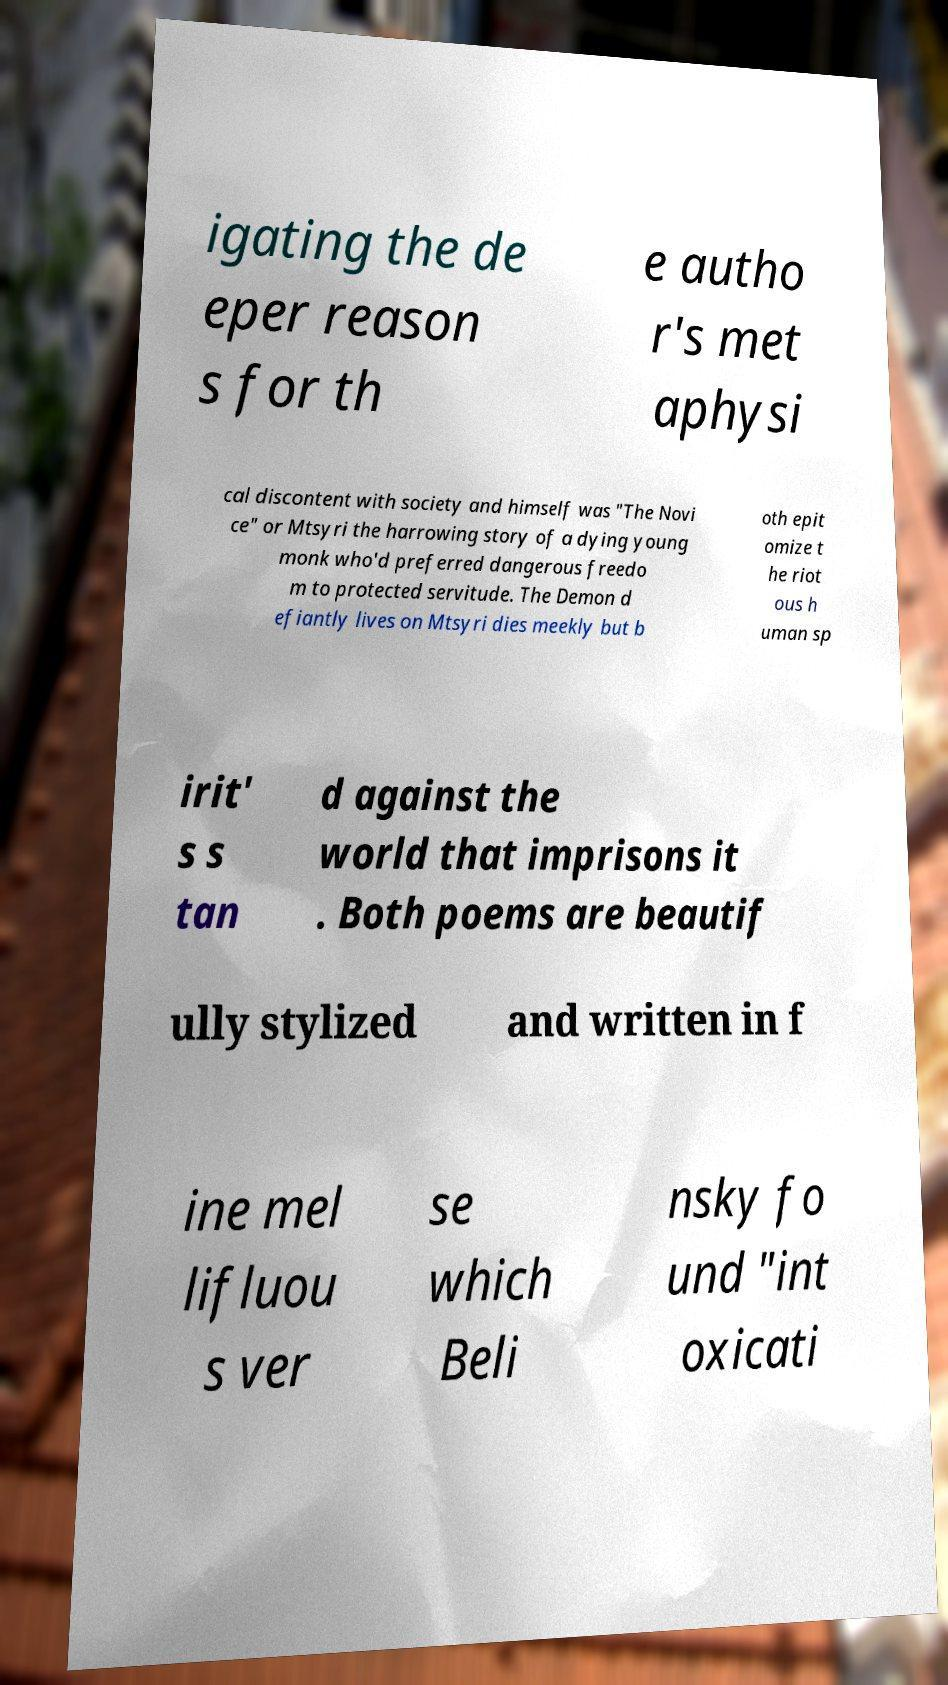Please read and relay the text visible in this image. What does it say? igating the de eper reason s for th e autho r's met aphysi cal discontent with society and himself was "The Novi ce" or Mtsyri the harrowing story of a dying young monk who'd preferred dangerous freedo m to protected servitude. The Demon d efiantly lives on Mtsyri dies meekly but b oth epit omize t he riot ous h uman sp irit' s s tan d against the world that imprisons it . Both poems are beautif ully stylized and written in f ine mel lifluou s ver se which Beli nsky fo und "int oxicati 